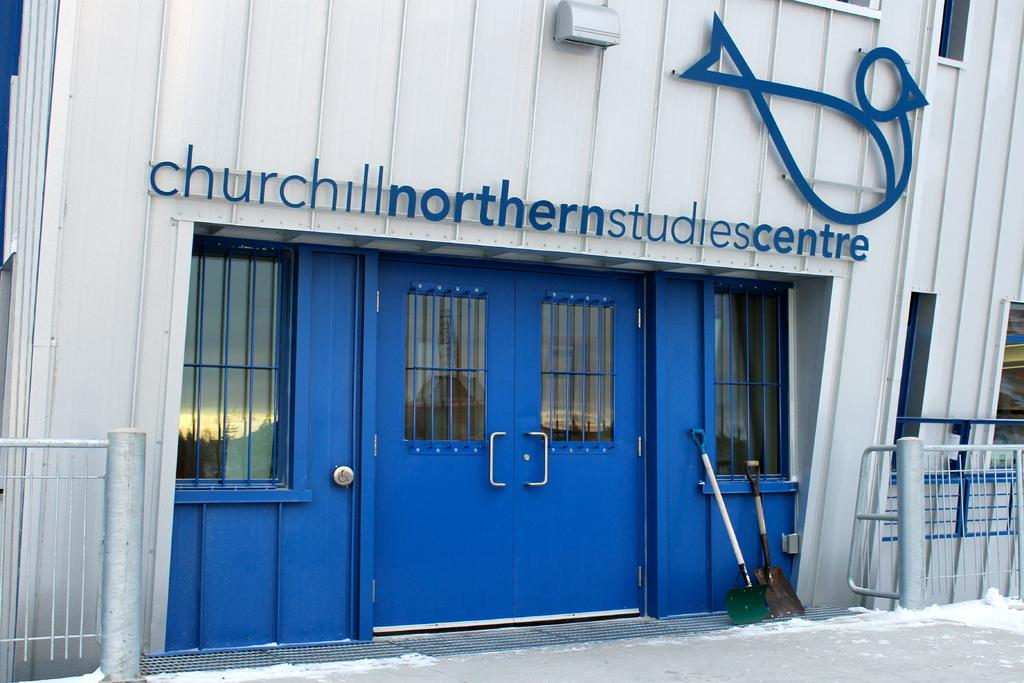Provide a one-sentence caption for the provided image. The front of a studio centre that is blue and white. 